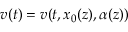<formula> <loc_0><loc_0><loc_500><loc_500>v ( t ) = v ( t , x _ { 0 } ( z ) , \alpha ( z ) )</formula> 